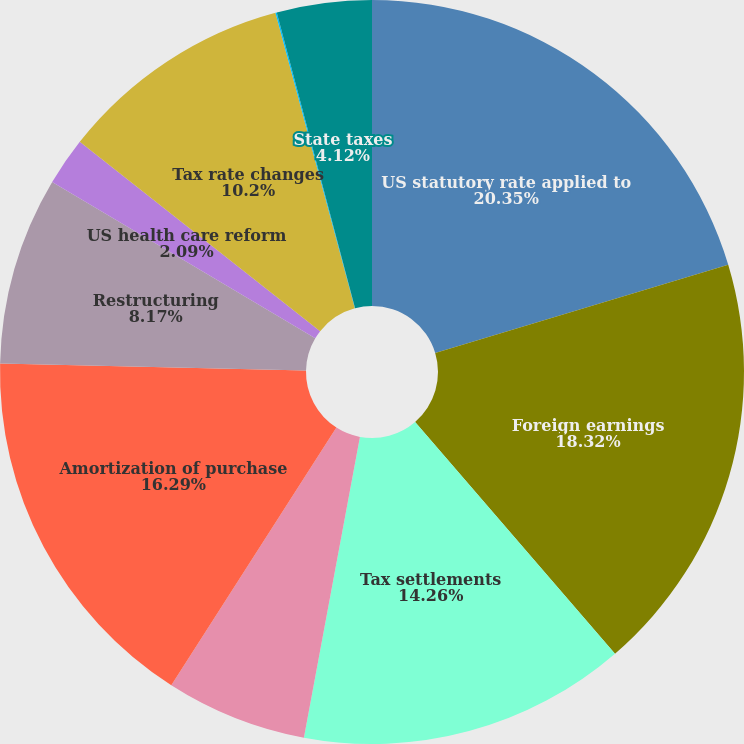Convert chart. <chart><loc_0><loc_0><loc_500><loc_500><pie_chart><fcel>US statutory rate applied to<fcel>Foreign earnings<fcel>Tax settlements<fcel>Unremitted foreign earnings<fcel>Amortization of purchase<fcel>Restructuring<fcel>US health care reform<fcel>Tax rate changes<fcel>IPR&D impairment charges<fcel>State taxes<nl><fcel>20.35%<fcel>18.32%<fcel>14.26%<fcel>6.14%<fcel>16.29%<fcel>8.17%<fcel>2.09%<fcel>10.2%<fcel>0.06%<fcel>4.12%<nl></chart> 